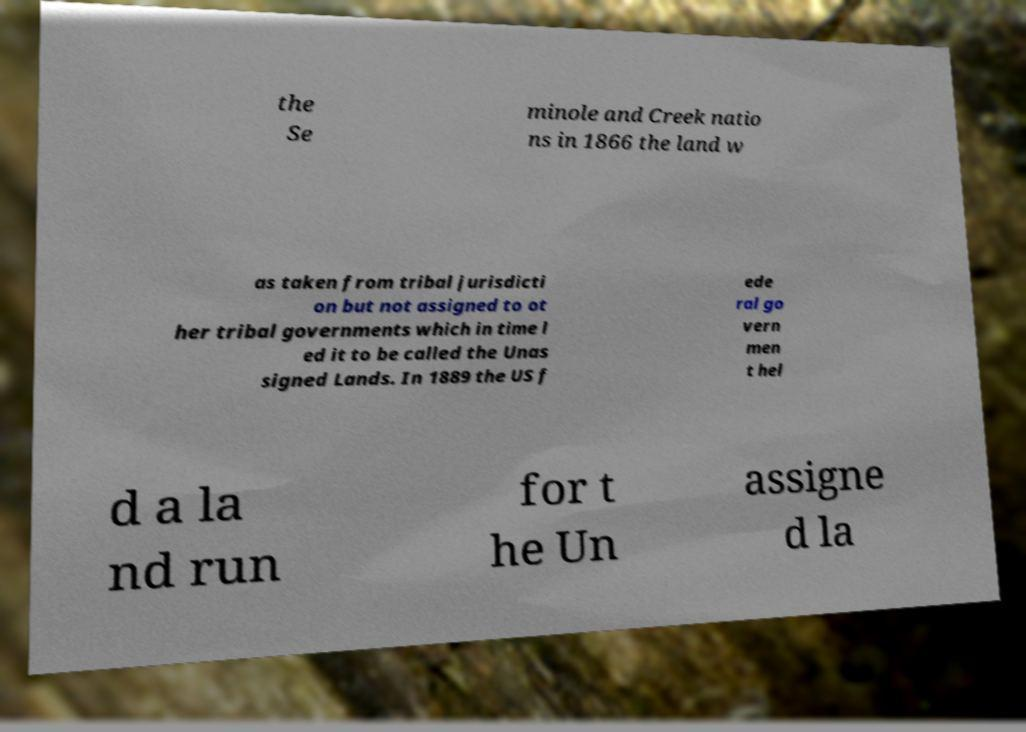Please identify and transcribe the text found in this image. the Se minole and Creek natio ns in 1866 the land w as taken from tribal jurisdicti on but not assigned to ot her tribal governments which in time l ed it to be called the Unas signed Lands. In 1889 the US f ede ral go vern men t hel d a la nd run for t he Un assigne d la 